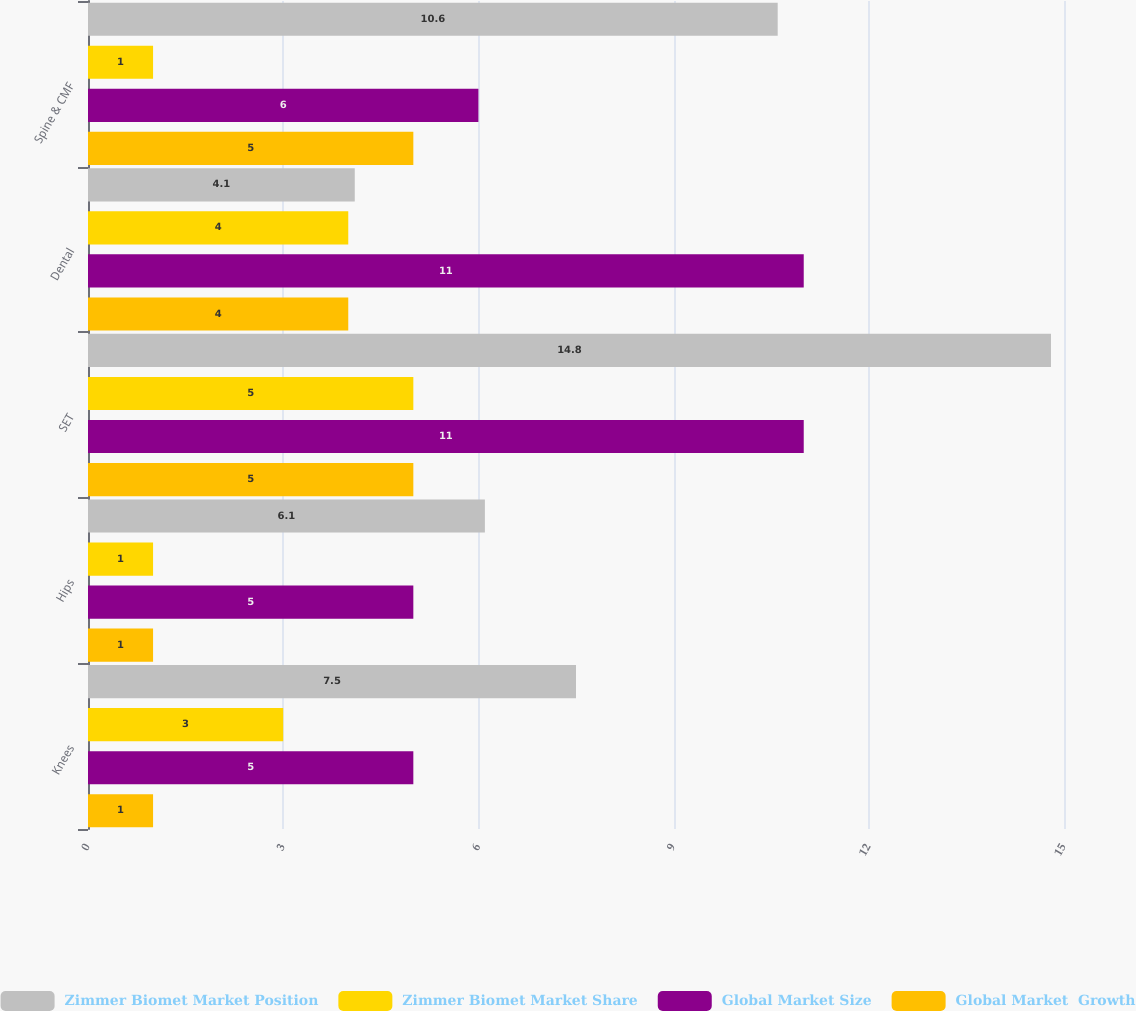Convert chart to OTSL. <chart><loc_0><loc_0><loc_500><loc_500><stacked_bar_chart><ecel><fcel>Knees<fcel>Hips<fcel>SET<fcel>Dental<fcel>Spine & CMF<nl><fcel>Zimmer Biomet Market Position<fcel>7.5<fcel>6.1<fcel>14.8<fcel>4.1<fcel>10.6<nl><fcel>Zimmer Biomet Market Share<fcel>3<fcel>1<fcel>5<fcel>4<fcel>1<nl><fcel>Global Market Size<fcel>5<fcel>5<fcel>11<fcel>11<fcel>6<nl><fcel>Global Market  Growth<fcel>1<fcel>1<fcel>5<fcel>4<fcel>5<nl></chart> 